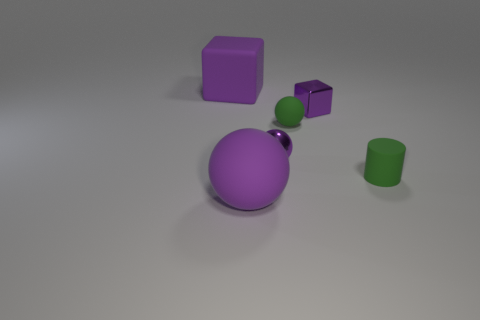Is there a block that has the same material as the green cylinder?
Give a very brief answer. Yes. There is a small purple object in front of the matte sphere that is behind the small green cylinder; what is it made of?
Provide a succinct answer. Metal. What size is the purple rubber ball in front of the small block?
Make the answer very short. Large. Do the big cube and the cube that is right of the large ball have the same color?
Provide a succinct answer. Yes. Is there a tiny object that has the same color as the big cube?
Provide a short and direct response. Yes. Is the material of the tiny cylinder the same as the big purple object on the right side of the purple rubber block?
Offer a very short reply. Yes. What number of small objects are purple shiny spheres or purple rubber spheres?
Your answer should be compact. 1. There is a small object that is the same color as the small block; what is its material?
Offer a terse response. Metal. Is the number of spheres less than the number of tiny red metallic blocks?
Provide a short and direct response. No. There is a purple sphere in front of the tiny green rubber cylinder; is it the same size as the purple block that is on the left side of the tiny purple block?
Offer a very short reply. Yes. 